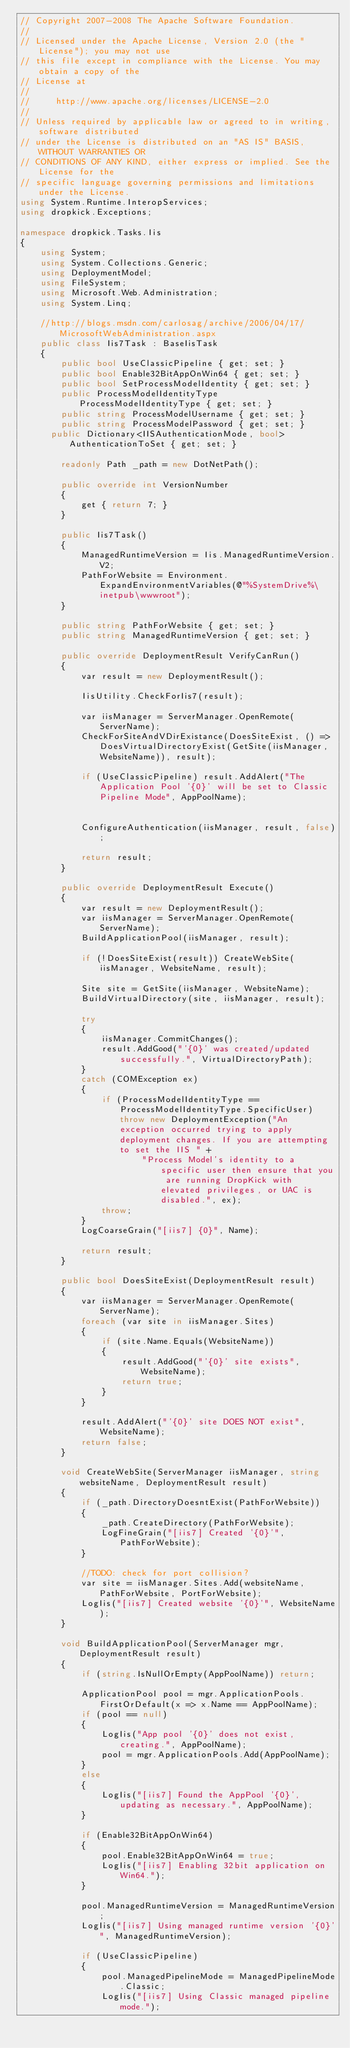<code> <loc_0><loc_0><loc_500><loc_500><_C#_>// Copyright 2007-2008 The Apache Software Foundation.
// 
// Licensed under the Apache License, Version 2.0 (the "License"); you may not use 
// this file except in compliance with the License. You may obtain a copy of the 
// License at 
// 
//     http://www.apache.org/licenses/LICENSE-2.0 
// 
// Unless required by applicable law or agreed to in writing, software distributed 
// under the License is distributed on an "AS IS" BASIS, WITHOUT WARRANTIES OR 
// CONDITIONS OF ANY KIND, either express or implied. See the License for the 
// specific language governing permissions and limitations under the License.
using System.Runtime.InteropServices;
using dropkick.Exceptions;

namespace dropkick.Tasks.Iis
{
    using System;
    using System.Collections.Generic;
    using DeploymentModel;
    using FileSystem;
    using Microsoft.Web.Administration;
    using System.Linq;

    //http://blogs.msdn.com/carlosag/archive/2006/04/17/MicrosoftWebAdministration.aspx
    public class Iis7Task : BaseIisTask
    {
        public bool UseClassicPipeline { get; set; }
        public bool Enable32BitAppOnWin64 { get; set; }
		public bool SetProcessModelIdentity { get; set; }
    	public ProcessModelIdentityType ProcessModelIdentityType { get; set; }
		public string ProcessModelUsername { get; set; }
		public string ProcessModelPassword { get; set; }
      public Dictionary<IISAuthenticationMode, bool> AuthenticationToSet { get; set; }

        readonly Path _path = new DotNetPath();

    	public override int VersionNumber
        {
            get { return 7; }
        }

        public Iis7Task()
        {
            ManagedRuntimeVersion = Iis.ManagedRuntimeVersion.V2;
            PathForWebsite = Environment.ExpandEnvironmentVariables(@"%SystemDrive%\inetpub\wwwroot");
        }

        public string PathForWebsite { get; set; }
        public string ManagedRuntimeVersion { get; set; }

        public override DeploymentResult VerifyCanRun()
        {
            var result = new DeploymentResult();

            IisUtility.CheckForIis7(result);

            var iisManager = ServerManager.OpenRemote(ServerName);
            CheckForSiteAndVDirExistance(DoesSiteExist, () => DoesVirtualDirectoryExist(GetSite(iisManager, WebsiteName)), result);

            if (UseClassicPipeline) result.AddAlert("The Application Pool '{0}' will be set to Classic Pipeline Mode", AppPoolName);


            ConfigureAuthentication(iisManager, result, false);

            return result;
        }

        public override DeploymentResult Execute()
        {
            var result = new DeploymentResult();
            var iisManager = ServerManager.OpenRemote(ServerName);
            BuildApplicationPool(iisManager, result);

            if (!DoesSiteExist(result)) CreateWebSite(iisManager, WebsiteName, result);

            Site site = GetSite(iisManager, WebsiteName);
        	BuildVirtualDirectory(site, iisManager, result);

        	try
        	{
				iisManager.CommitChanges();
                result.AddGood("'{0}' was created/updated successfully.", VirtualDirectoryPath);
        	}
        	catch (COMException ex)
        	{
        		if (ProcessModelIdentityType == ProcessModelIdentityType.SpecificUser) throw new DeploymentException("An exception occurred trying to apply deployment changes. If you are attempting to set the IIS " +
						"Process Model's identity to a specific user then ensure that you are running DropKick with elevated privileges, or UAC is disabled.", ex);
        		throw;
        	}
        	LogCoarseGrain("[iis7] {0}", Name);
            
            return result;
        }

        public bool DoesSiteExist(DeploymentResult result)
        {
            var iisManager = ServerManager.OpenRemote(ServerName);
            foreach (var site in iisManager.Sites)
            {
                if (site.Name.Equals(WebsiteName))
                {
                    result.AddGood("'{0}' site exists", WebsiteName);
                    return true;
                }
            }

            result.AddAlert("'{0}' site DOES NOT exist", WebsiteName);
            return false;
        }

        void CreateWebSite(ServerManager iisManager, string websiteName, DeploymentResult result)
        {
            if (_path.DirectoryDoesntExist(PathForWebsite))
            {
                _path.CreateDirectory(PathForWebsite);
                LogFineGrain("[iis7] Created '{0}'", PathForWebsite);
            }

            //TODO: check for port collision?
            var site = iisManager.Sites.Add(websiteName, PathForWebsite, PortForWebsite);
            LogIis("[iis7] Created website '{0}'", WebsiteName);
        }

        void BuildApplicationPool(ServerManager mgr, DeploymentResult result)
        {
            if (string.IsNullOrEmpty(AppPoolName)) return;

        	ApplicationPool pool = mgr.ApplicationPools.FirstOrDefault(x => x.Name == AppPoolName);
			if (pool == null)
			{
				LogIis("App pool '{0}' does not exist, creating.", AppPoolName);
				pool = mgr.ApplicationPools.Add(AppPoolName);
			}
			else
            {
                LogIis("[iis7] Found the AppPool '{0}', updating as necessary.", AppPoolName);
            }

			if (Enable32BitAppOnWin64)
			{
				pool.Enable32BitAppOnWin64 = true;
				LogIis("[iis7] Enabling 32bit application on Win64.");
			}

        	pool.ManagedRuntimeVersion = ManagedRuntimeVersion;
			LogIis("[iis7] Using managed runtime version '{0}'", ManagedRuntimeVersion);

			if (UseClassicPipeline)
			{
				pool.ManagedPipelineMode = ManagedPipelineMode.Classic;
				LogIis("[iis7] Using Classic managed pipeline mode.");</code> 